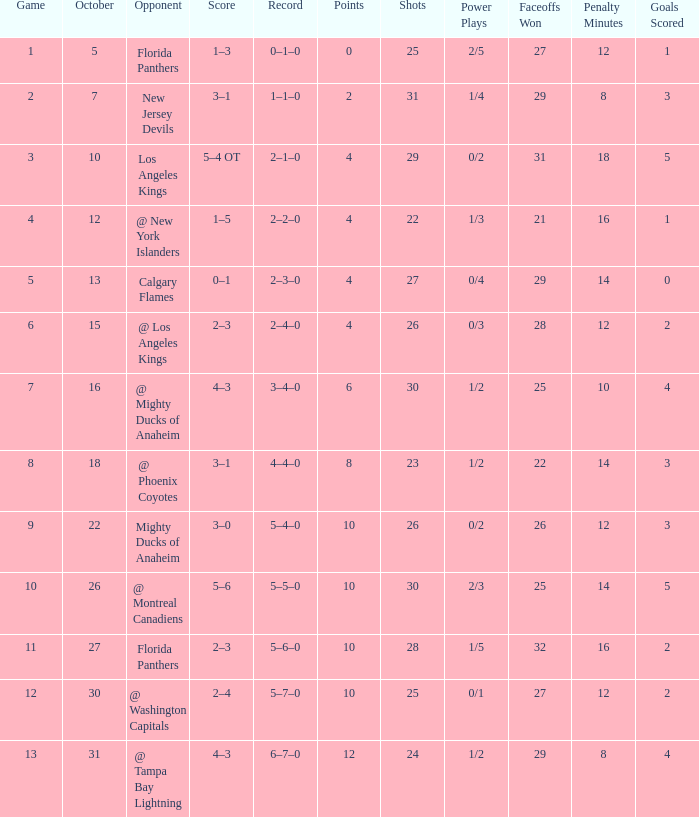What team has a score of 2 3–1. 